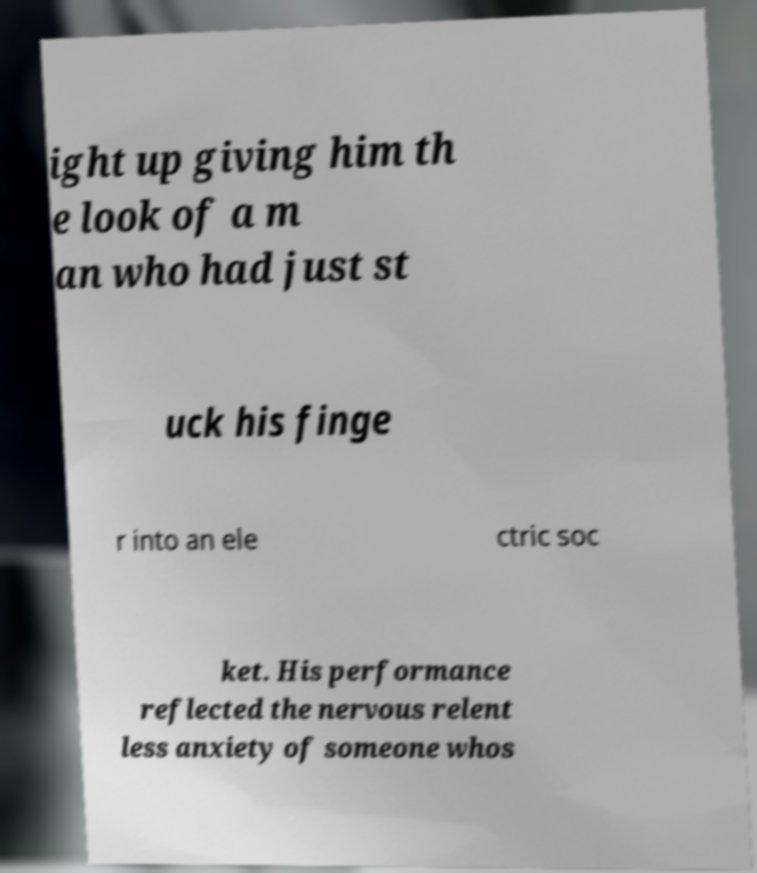What messages or text are displayed in this image? I need them in a readable, typed format. ight up giving him th e look of a m an who had just st uck his finge r into an ele ctric soc ket. His performance reflected the nervous relent less anxiety of someone whos 